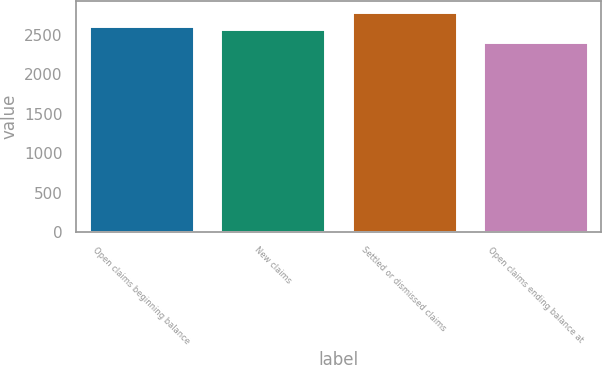Convert chart. <chart><loc_0><loc_0><loc_500><loc_500><bar_chart><fcel>Open claims beginning balance<fcel>New claims<fcel>Settled or dismissed claims<fcel>Open claims ending balance at<nl><fcel>2618<fcel>2573<fcel>2787<fcel>2404<nl></chart> 